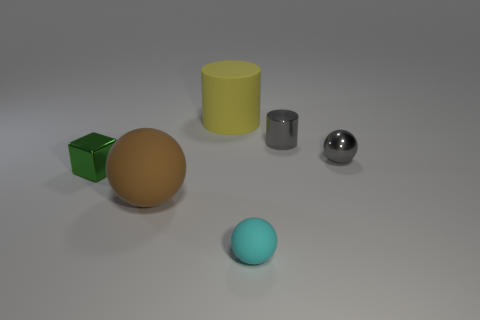Subtract all small spheres. How many spheres are left? 1 Subtract 1 cylinders. How many cylinders are left? 1 Subtract all cyan balls. How many balls are left? 2 Add 2 cyan rubber spheres. How many objects exist? 8 Subtract all green balls. Subtract all brown cylinders. How many balls are left? 3 Subtract all cylinders. How many objects are left? 4 Subtract 1 yellow cylinders. How many objects are left? 5 Subtract all brown balls. Subtract all large gray metallic things. How many objects are left? 5 Add 4 green cubes. How many green cubes are left? 5 Add 5 tiny green metallic cubes. How many tiny green metallic cubes exist? 6 